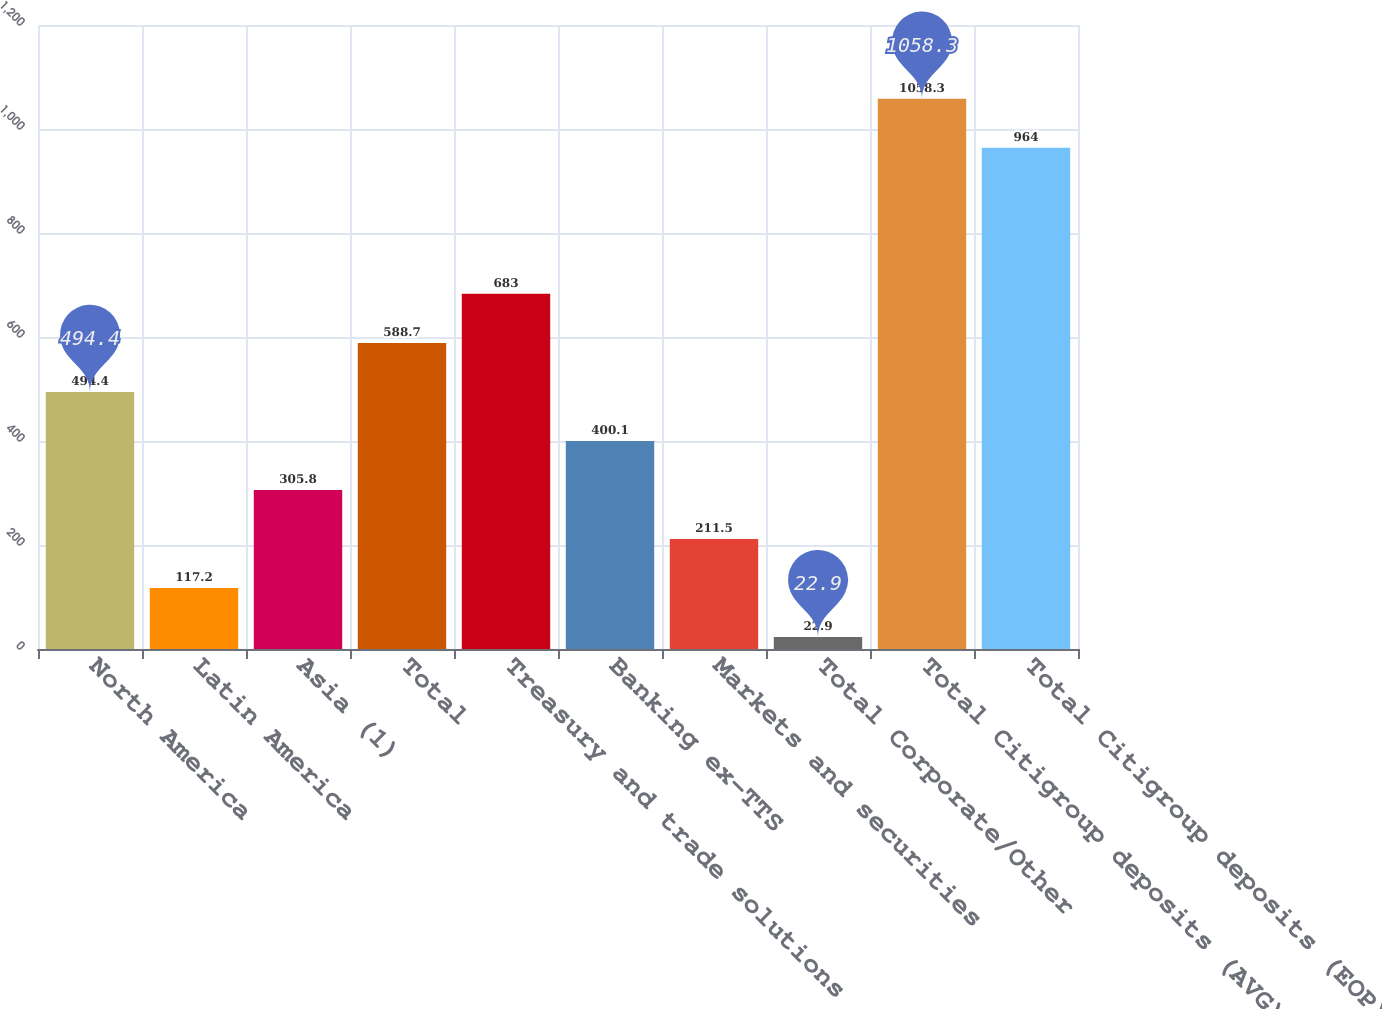Convert chart. <chart><loc_0><loc_0><loc_500><loc_500><bar_chart><fcel>North America<fcel>Latin America<fcel>Asia (1)<fcel>Total<fcel>Treasury and trade solutions<fcel>Banking ex-TTS<fcel>Markets and securities<fcel>Total Corporate/Other<fcel>Total Citigroup deposits (AVG)<fcel>Total Citigroup deposits (EOP)<nl><fcel>494.4<fcel>117.2<fcel>305.8<fcel>588.7<fcel>683<fcel>400.1<fcel>211.5<fcel>22.9<fcel>1058.3<fcel>964<nl></chart> 